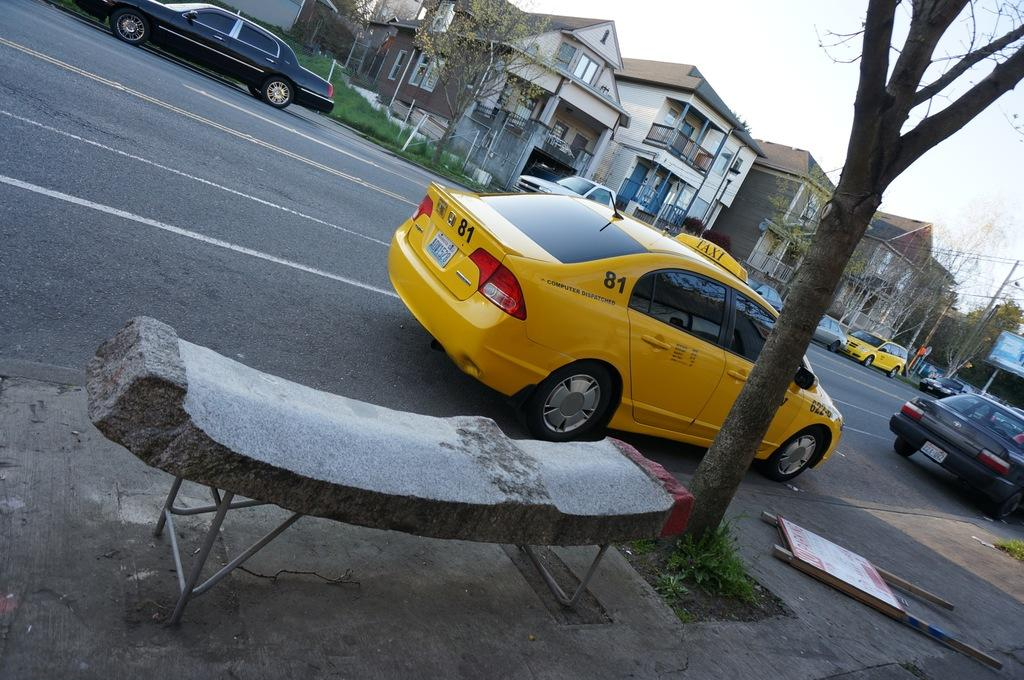Provide a one-sentence caption for the provided image. A yellow cab that has the numbers 81 on it. 